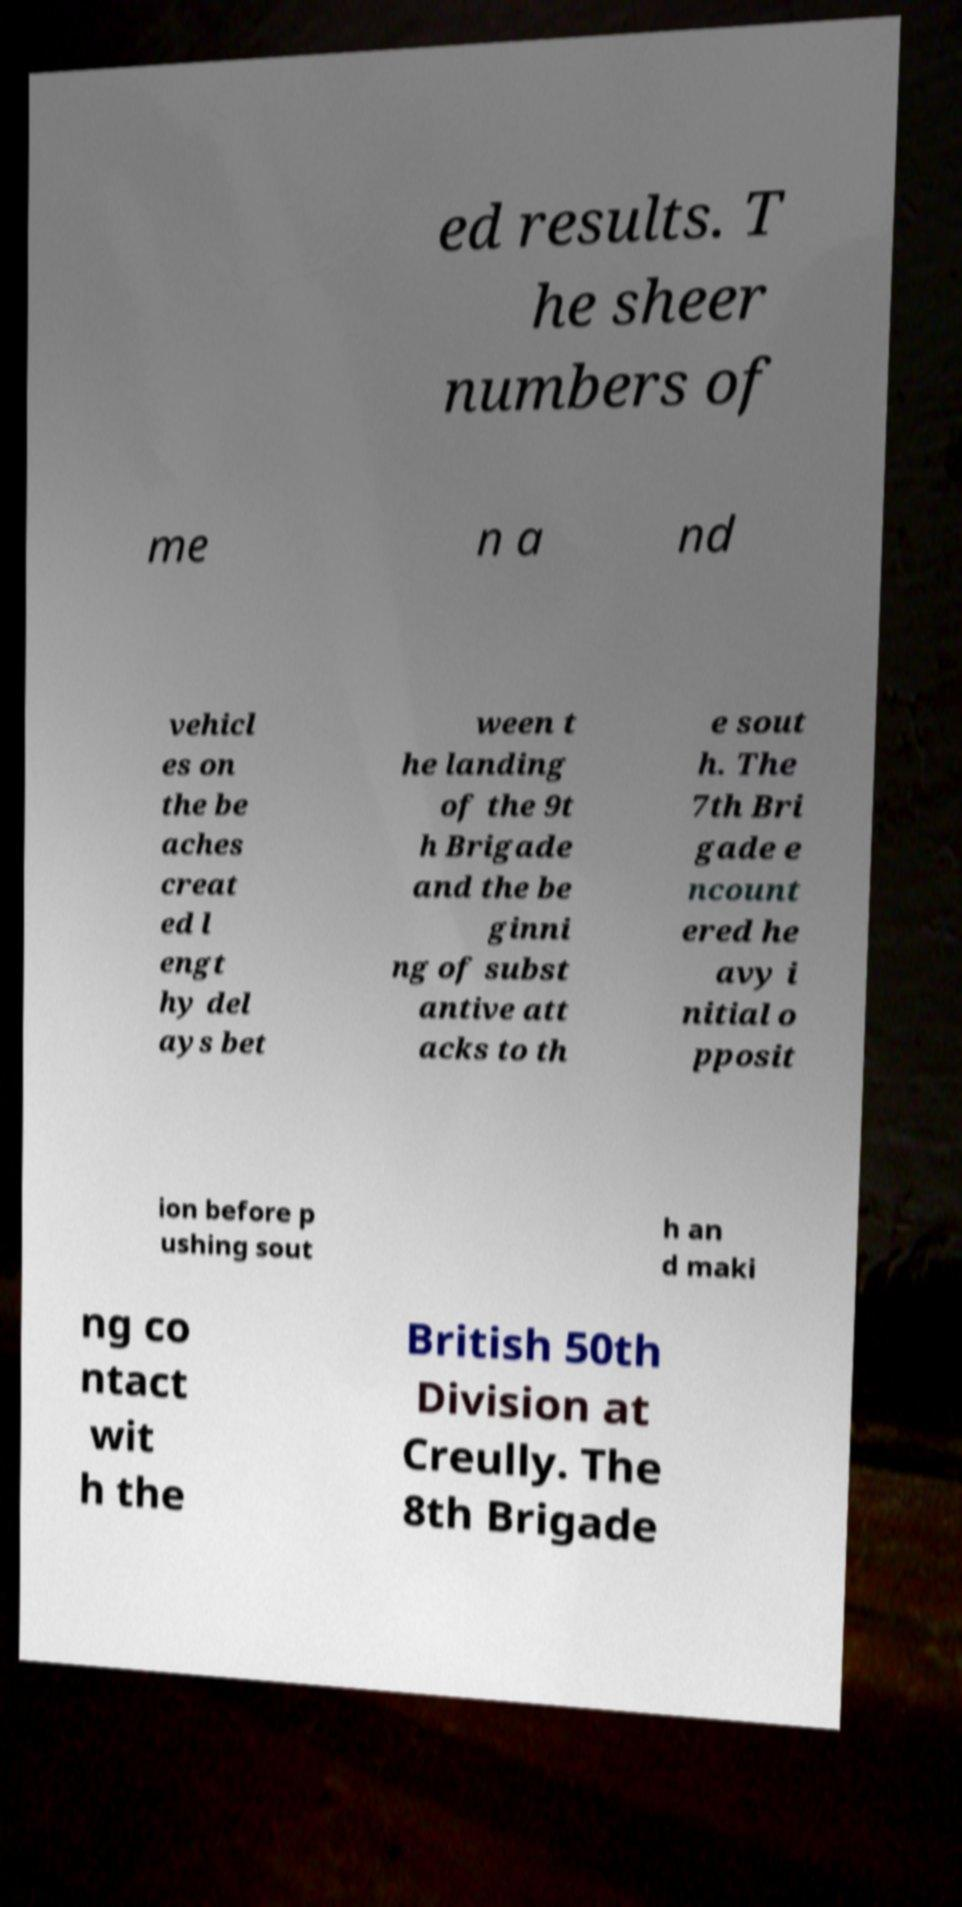Could you extract and type out the text from this image? ed results. T he sheer numbers of me n a nd vehicl es on the be aches creat ed l engt hy del ays bet ween t he landing of the 9t h Brigade and the be ginni ng of subst antive att acks to th e sout h. The 7th Bri gade e ncount ered he avy i nitial o pposit ion before p ushing sout h an d maki ng co ntact wit h the British 50th Division at Creully. The 8th Brigade 